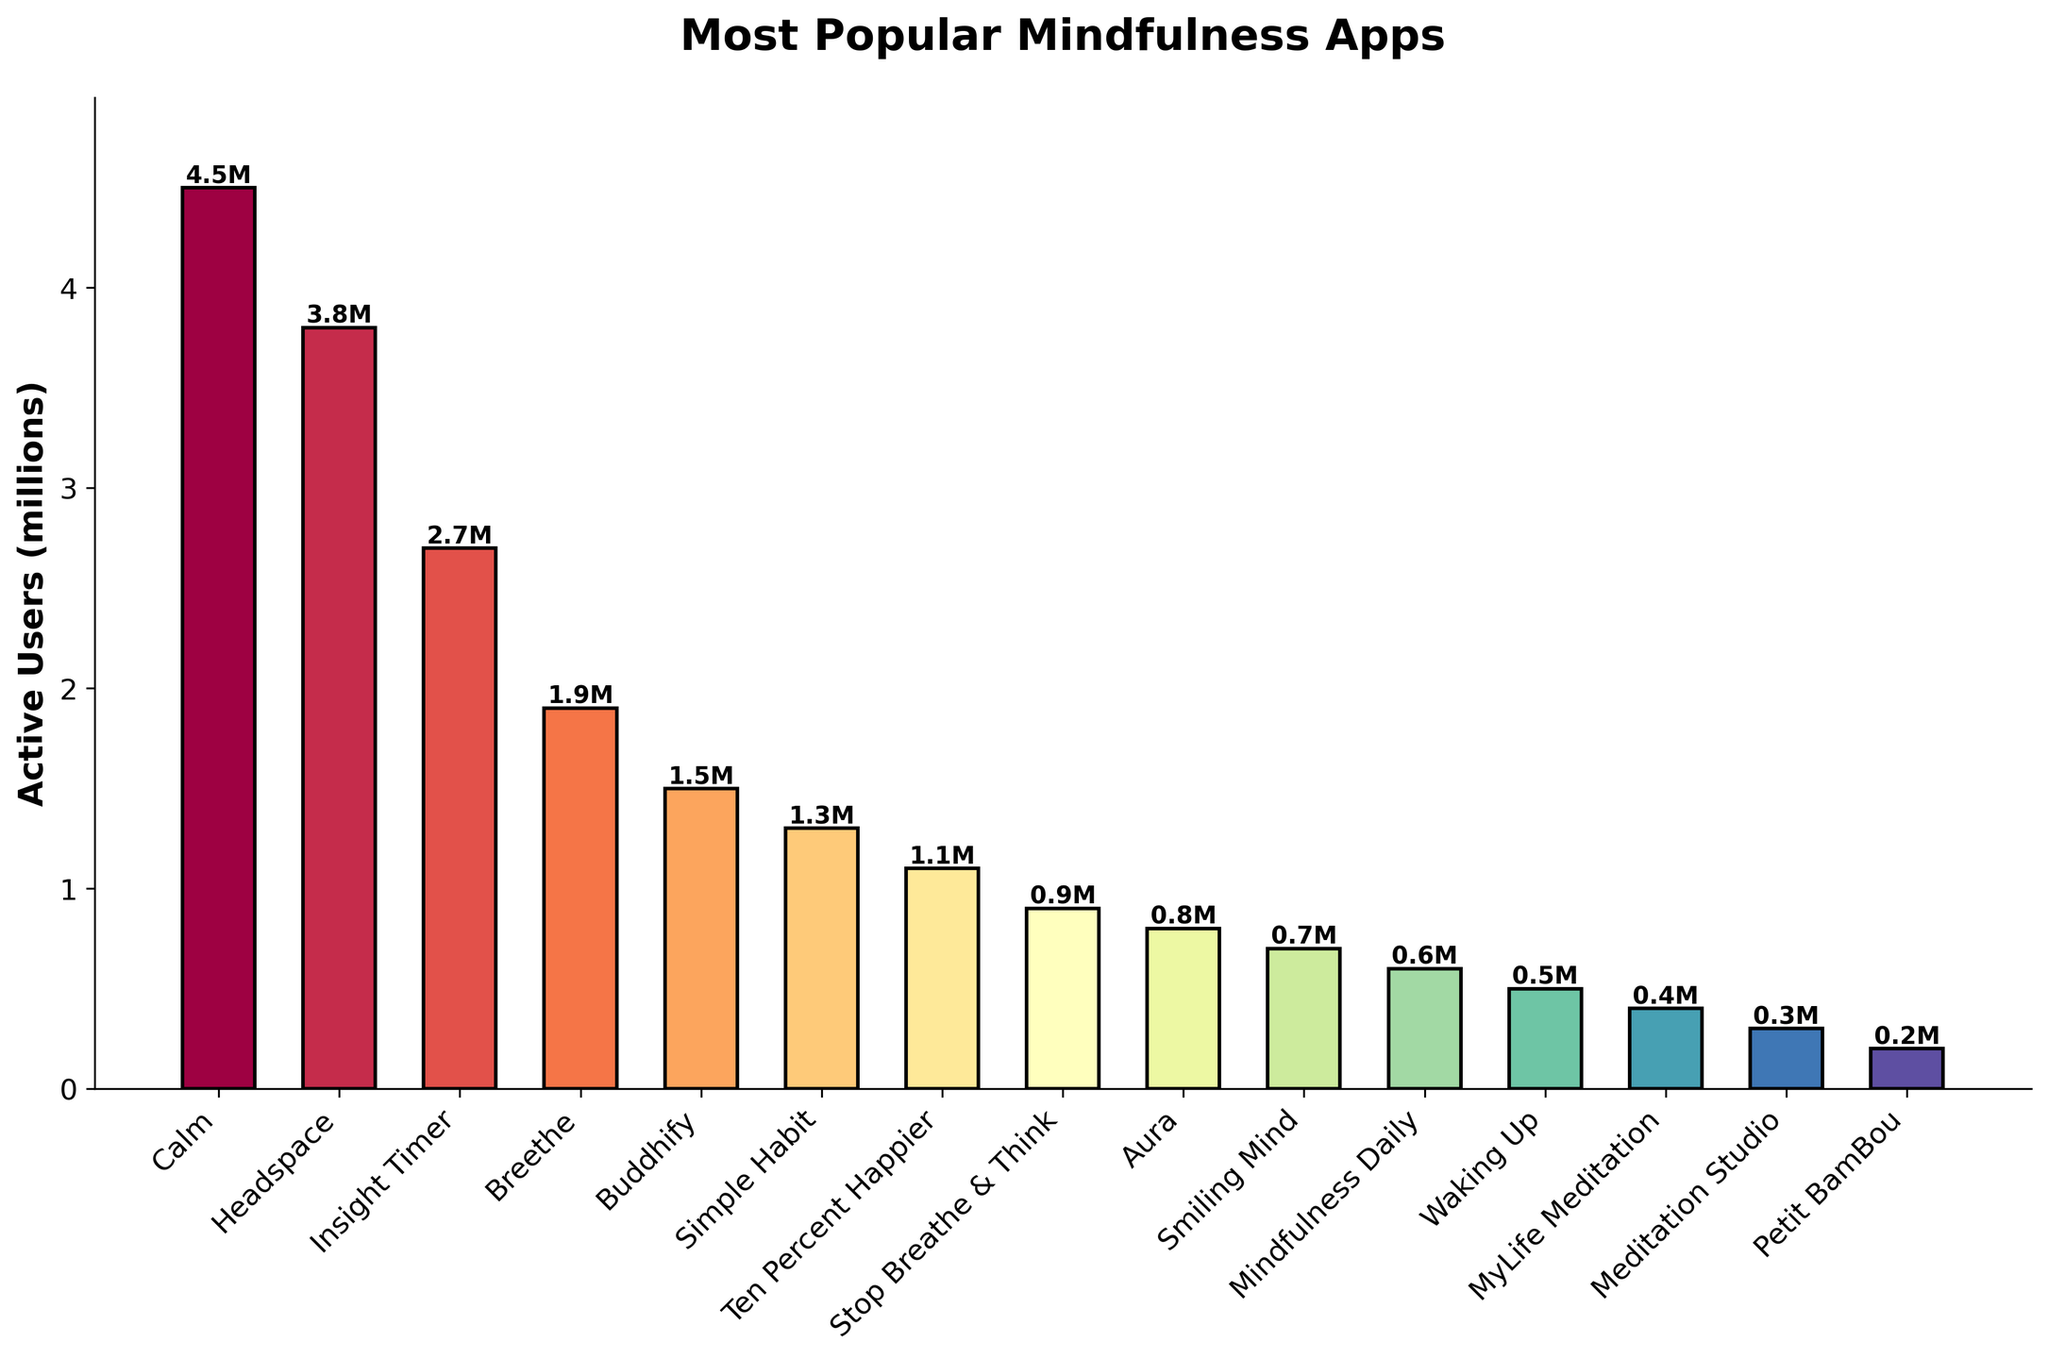How many active users do the top three mindfulness apps have in total? First, identify the top three apps by active users from the bar chart: Calm, Headspace, and Insight Timer. Then, sum their active users: 4.5M (Calm) + 3.8M (Headspace) + 2.7M (Insight Timer) = 11M
Answer: 11 million Which app has the least number of active users, and how many are there? By examining the shortest bar in the chart, identify the app with the fewest active users, which is Petit BamBou with 0.2 million active users
Answer: Petit BamBou, 0.2 million What's the difference in active users between the app with the most and the app with the least active users? Identify the app with the most users (Calm, 4.5M) and the app with the least users (Petit BamBou, 0.2M). Calculate the difference: 4.5M - 0.2M = 4.3M
Answer: 4.3 million Which apps have more than 1 million active users but less than 3 million active users? Identify bars that are taller than 1M but shorter than 3M. These are Insight Timer (2.7M), Breethe (1.9M), and Buddhify (1.5M)
Answer: Insight Timer, Breethe, Buddhify Do any two apps about the same number of active users? Compare and provide the answer. Check if any two bars have nearly equal height. Breethe (1.9M) and Buddhify (1.5M) are similar but not the same, but no two bars are exactly equal
Answer: None By how much does Headspace lag behind Calm in terms of active users? Subtract the number of active users of Headspace from Calm: 4.5M (Calm) - 3.8M (Headspace) = 0.7M
Answer: 0.7 million What is the average number of active users for all the apps shown? Sum all active users and divide by the number of apps. Sum = 4.5 + 3.8 + 2.7 + 1.9 + 1.5 + 1.3 + 1.1 + 0.9 + 0.8 + 0.7 + 0.6 + 0.5 + 0.4 + 0.3 + 0.2 = 21.2M. Number of apps = 15. Average = 21.2M / 15 = 1.413M
Answer: 1.413 million How many apps have fewer than 1 million active users? Count all bars whose heights represent fewer than 1M active users: Stop Breathe & Think (0.9M), Aura (0.8M), Smiling Mind (0.7M), Mindfulness Daily (0.6M), Waking Up (0.5M), MyLife Meditation (0.4M), Meditation Studio (0.3M), and Petit BamBou (0.2M). There are 8 such apps
Answer: 8 